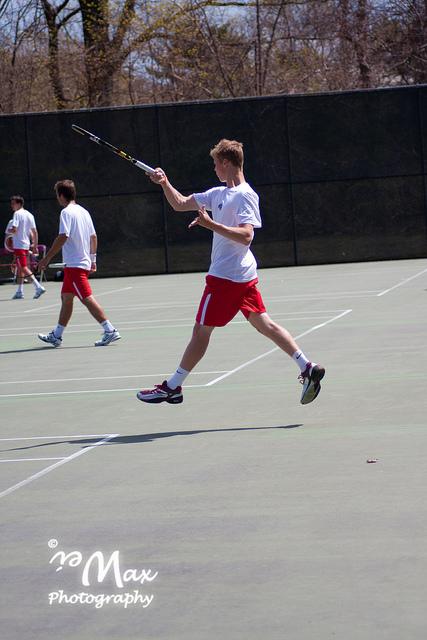Is this a professional portrait of the tennis game?
Keep it brief. Yes. What is the color of their shorts?
Short answer required. Red. Is the man's feet on the ground?
Short answer required. No. 